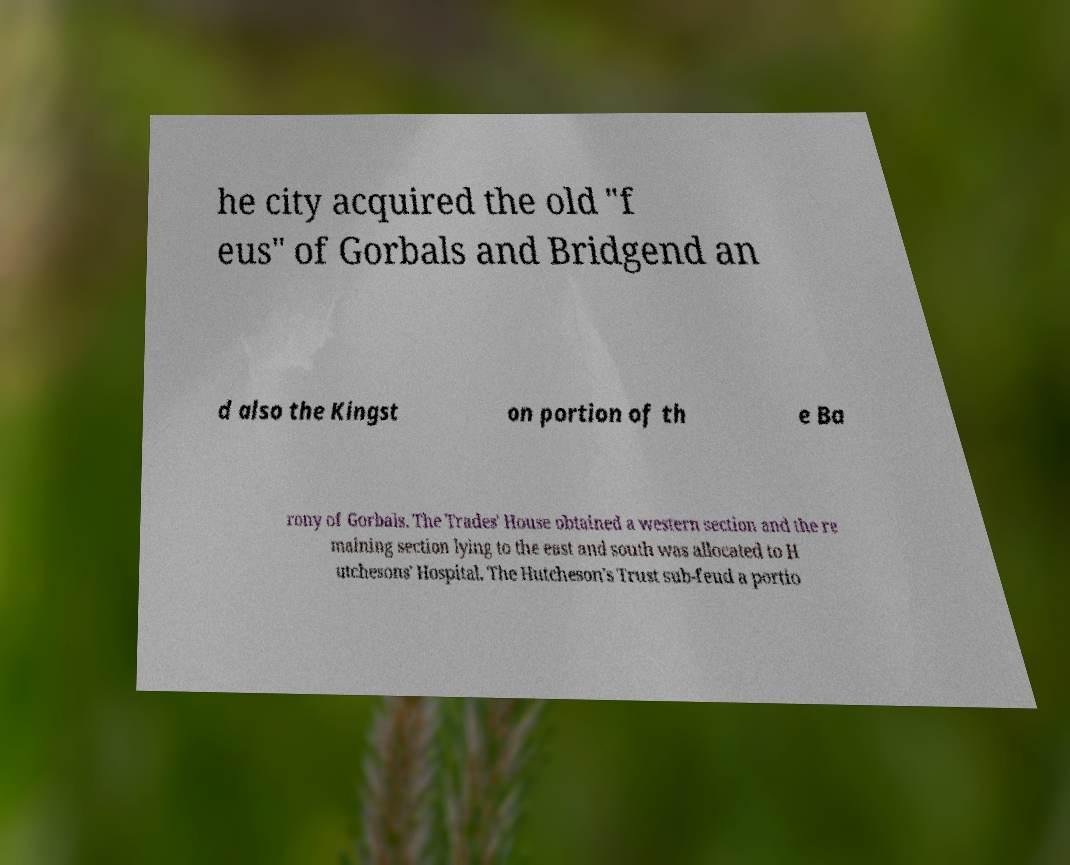There's text embedded in this image that I need extracted. Can you transcribe it verbatim? he city acquired the old "f eus" of Gorbals and Bridgend an d also the Kingst on portion of th e Ba rony of Gorbals. The Trades' House obtained a western section and the re maining section lying to the east and south was allocated to H utchesons' Hospital. The Hutcheson's Trust sub-feud a portio 